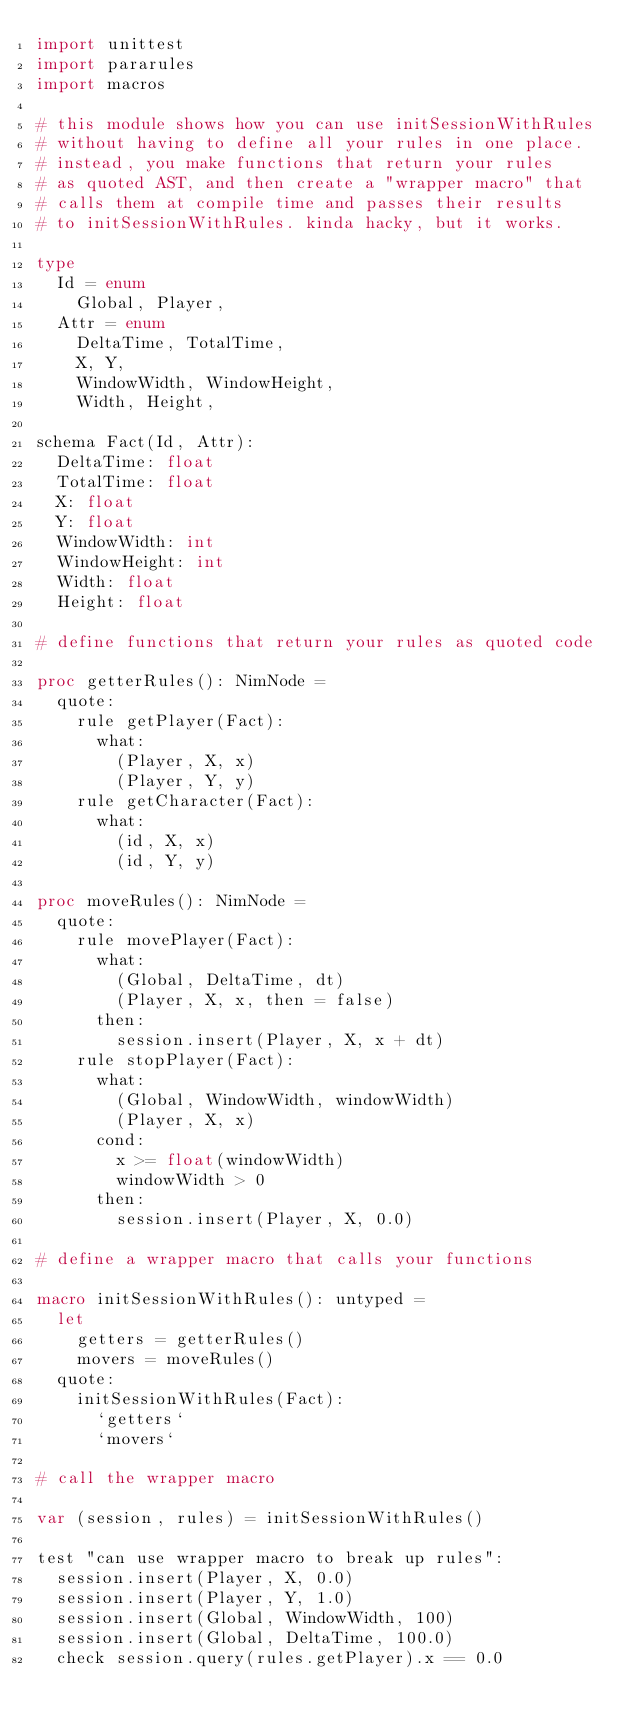Convert code to text. <code><loc_0><loc_0><loc_500><loc_500><_Nim_>import unittest
import pararules
import macros

# this module shows how you can use initSessionWithRules
# without having to define all your rules in one place.
# instead, you make functions that return your rules
# as quoted AST, and then create a "wrapper macro" that
# calls them at compile time and passes their results
# to initSessionWithRules. kinda hacky, but it works.

type
  Id = enum
    Global, Player,
  Attr = enum
    DeltaTime, TotalTime,
    X, Y,
    WindowWidth, WindowHeight,
    Width, Height,

schema Fact(Id, Attr):
  DeltaTime: float
  TotalTime: float
  X: float
  Y: float
  WindowWidth: int
  WindowHeight: int
  Width: float
  Height: float

# define functions that return your rules as quoted code

proc getterRules(): NimNode =
  quote:
    rule getPlayer(Fact):
      what:
        (Player, X, x)
        (Player, Y, y)
    rule getCharacter(Fact):
      what:
        (id, X, x)
        (id, Y, y)

proc moveRules(): NimNode =
  quote:
    rule movePlayer(Fact):
      what:
        (Global, DeltaTime, dt)
        (Player, X, x, then = false)
      then:
        session.insert(Player, X, x + dt)
    rule stopPlayer(Fact):
      what:
        (Global, WindowWidth, windowWidth)
        (Player, X, x)
      cond:
        x >= float(windowWidth)
        windowWidth > 0
      then:
        session.insert(Player, X, 0.0)

# define a wrapper macro that calls your functions

macro initSessionWithRules(): untyped =
  let
    getters = getterRules()
    movers = moveRules()
  quote:
    initSessionWithRules(Fact):
      `getters`
      `movers`

# call the wrapper macro

var (session, rules) = initSessionWithRules()

test "can use wrapper macro to break up rules":
  session.insert(Player, X, 0.0)
  session.insert(Player, Y, 1.0)
  session.insert(Global, WindowWidth, 100)
  session.insert(Global, DeltaTime, 100.0)
  check session.query(rules.getPlayer).x == 0.0

</code> 